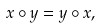Convert formula to latex. <formula><loc_0><loc_0><loc_500><loc_500>x \circ y = y \circ x ,</formula> 